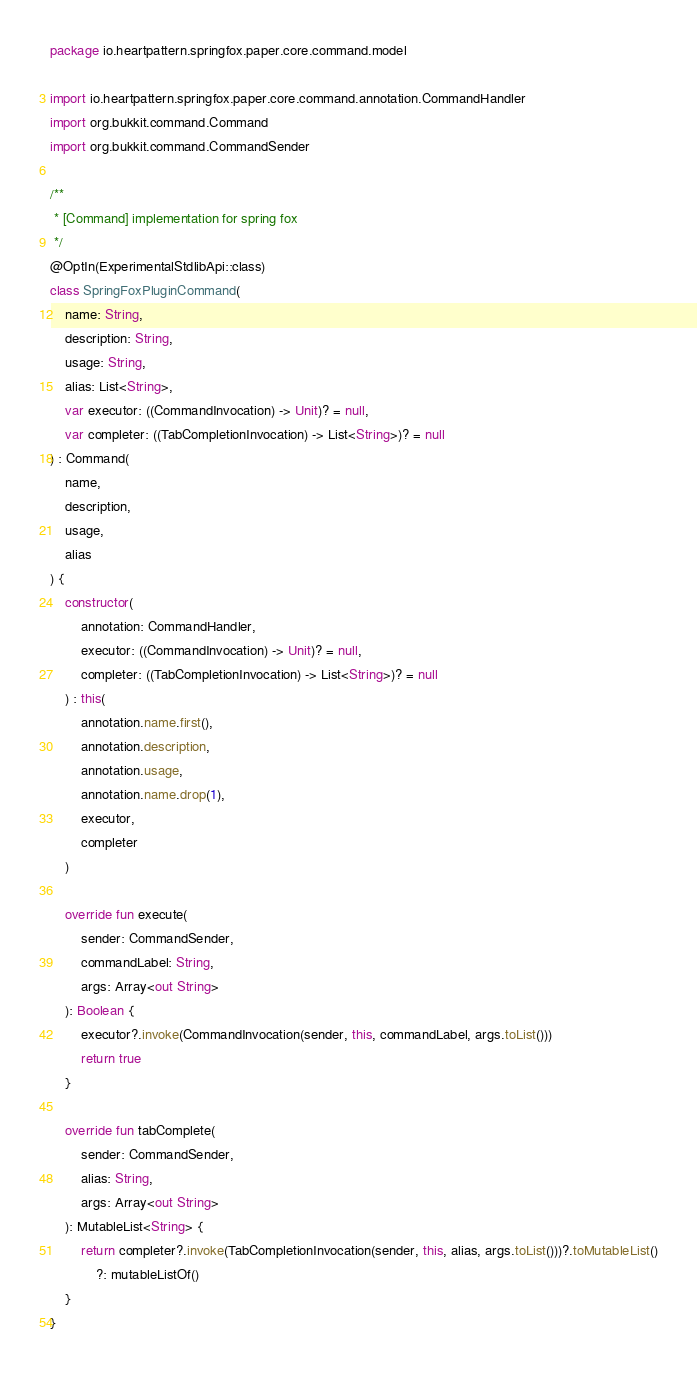Convert code to text. <code><loc_0><loc_0><loc_500><loc_500><_Kotlin_>package io.heartpattern.springfox.paper.core.command.model

import io.heartpattern.springfox.paper.core.command.annotation.CommandHandler
import org.bukkit.command.Command
import org.bukkit.command.CommandSender

/**
 * [Command] implementation for spring fox
 */
@OptIn(ExperimentalStdlibApi::class)
class SpringFoxPluginCommand(
    name: String,
    description: String,
    usage: String,
    alias: List<String>,
    var executor: ((CommandInvocation) -> Unit)? = null,
    var completer: ((TabCompletionInvocation) -> List<String>)? = null
) : Command(
    name,
    description,
    usage,
    alias
) {
    constructor(
        annotation: CommandHandler,
        executor: ((CommandInvocation) -> Unit)? = null,
        completer: ((TabCompletionInvocation) -> List<String>)? = null
    ) : this(
        annotation.name.first(),
        annotation.description,
        annotation.usage,
        annotation.name.drop(1),
        executor,
        completer
    )

    override fun execute(
        sender: CommandSender,
        commandLabel: String,
        args: Array<out String>
    ): Boolean {
        executor?.invoke(CommandInvocation(sender, this, commandLabel, args.toList()))
        return true
    }

    override fun tabComplete(
        sender: CommandSender,
        alias: String,
        args: Array<out String>
    ): MutableList<String> {
        return completer?.invoke(TabCompletionInvocation(sender, this, alias, args.toList()))?.toMutableList()
            ?: mutableListOf()
    }
}</code> 